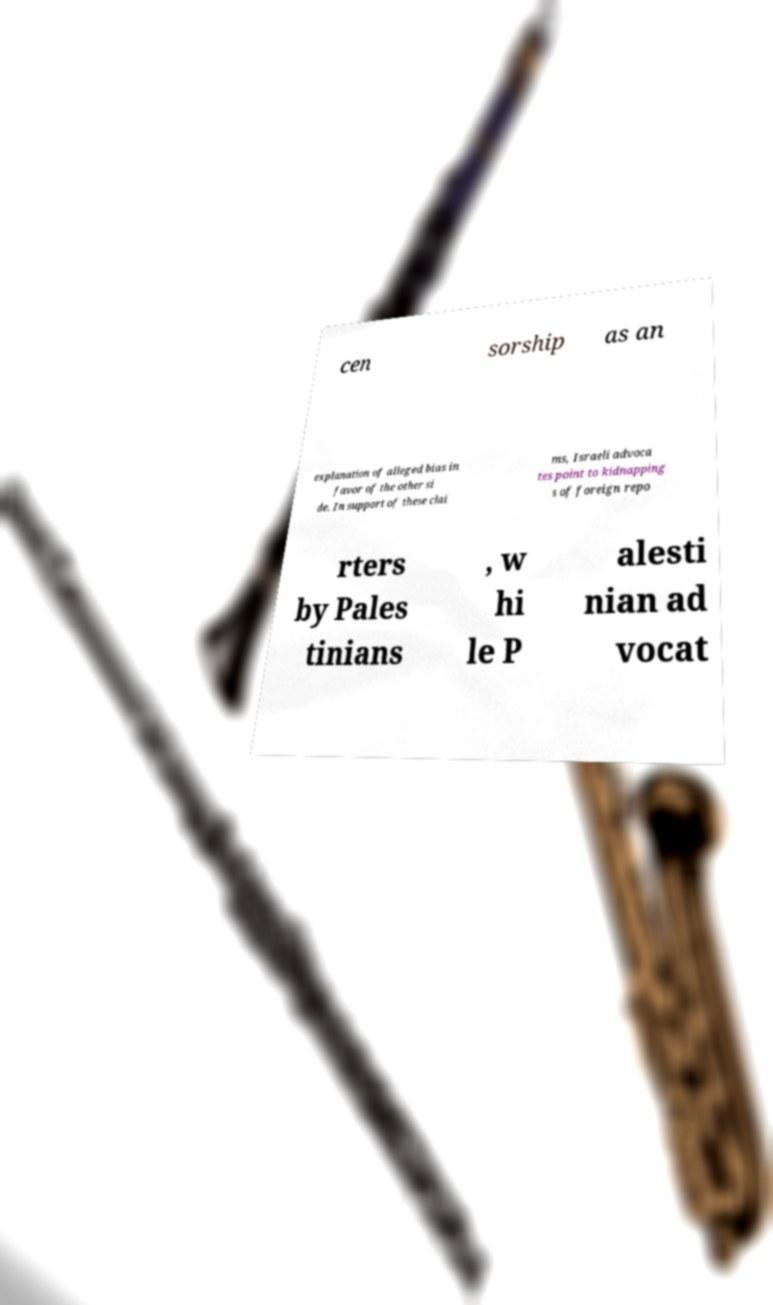Please identify and transcribe the text found in this image. cen sorship as an explanation of alleged bias in favor of the other si de. In support of these clai ms, Israeli advoca tes point to kidnapping s of foreign repo rters by Pales tinians , w hi le P alesti nian ad vocat 